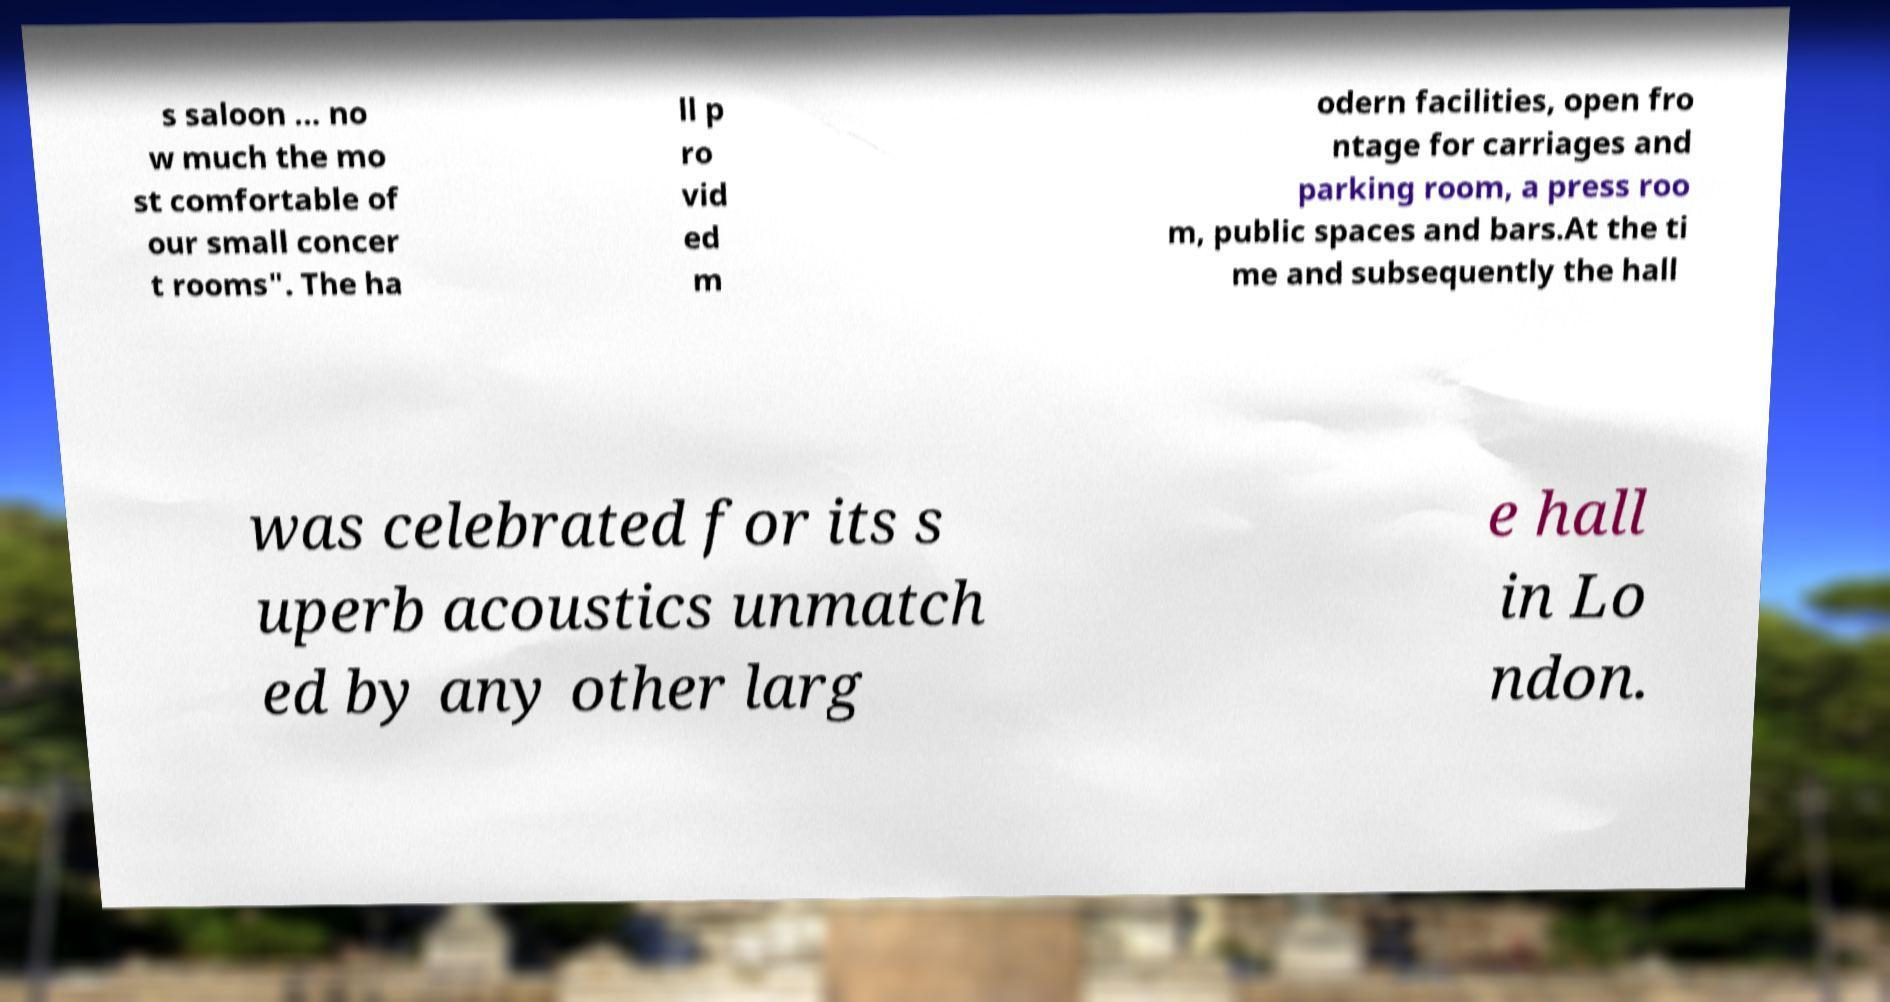For documentation purposes, I need the text within this image transcribed. Could you provide that? s saloon … no w much the mo st comfortable of our small concer t rooms". The ha ll p ro vid ed m odern facilities, open fro ntage for carriages and parking room, a press roo m, public spaces and bars.At the ti me and subsequently the hall was celebrated for its s uperb acoustics unmatch ed by any other larg e hall in Lo ndon. 